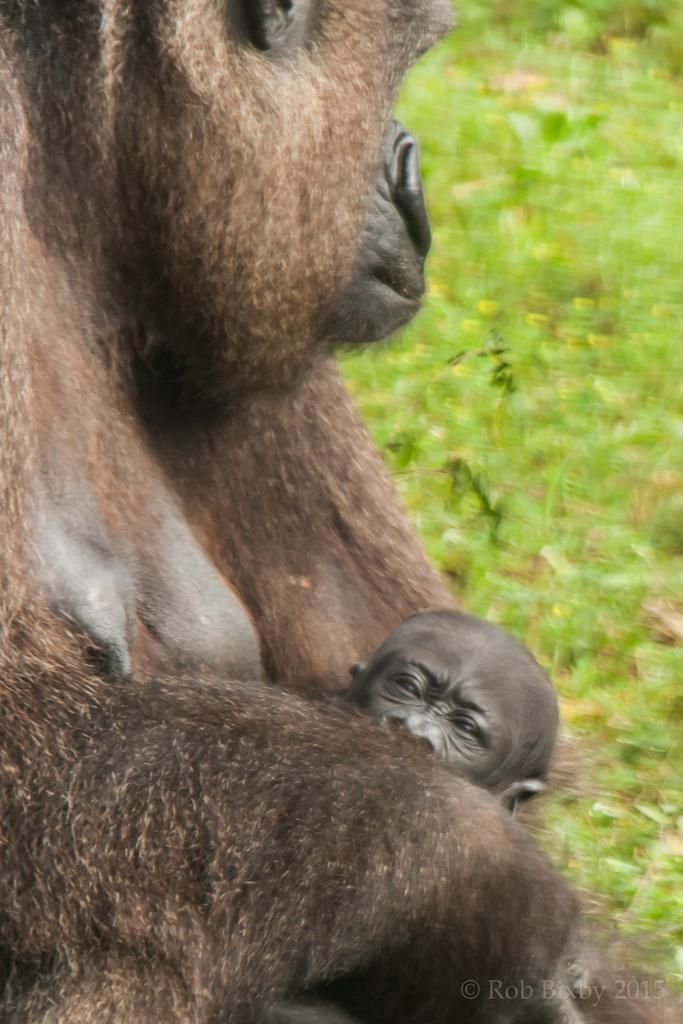What type of animal is the main subject of the picture? There is a gorilla in the picture. Can you describe the gorilla's offspring in the image? There is a gorilla baby in the picture. What type of vegetation is on the right side of the image? There is green grass on the right side of the image. Who is the creator of the gorilla in the image? The facts provided do not mention a creator for the gorilla in the image, as it is likely a photograph of a real gorilla. Is there a horse present in the image? No, there is no horse mentioned or visible in the image; it features a gorilla and a gorilla baby. 